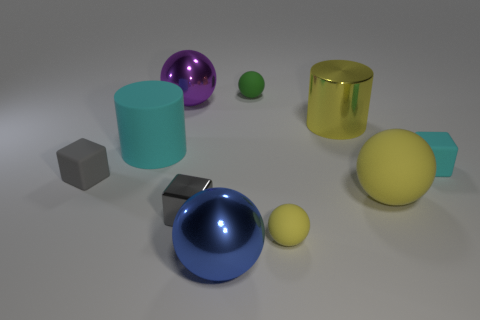Subtract all green spheres. How many spheres are left? 4 Subtract all purple spheres. How many spheres are left? 4 Subtract all gray balls. Subtract all cyan cubes. How many balls are left? 5 Subtract all blocks. How many objects are left? 7 Subtract 1 gray blocks. How many objects are left? 9 Subtract all gray shiny balls. Subtract all gray things. How many objects are left? 8 Add 8 small green rubber spheres. How many small green rubber spheres are left? 9 Add 3 big green things. How many big green things exist? 3 